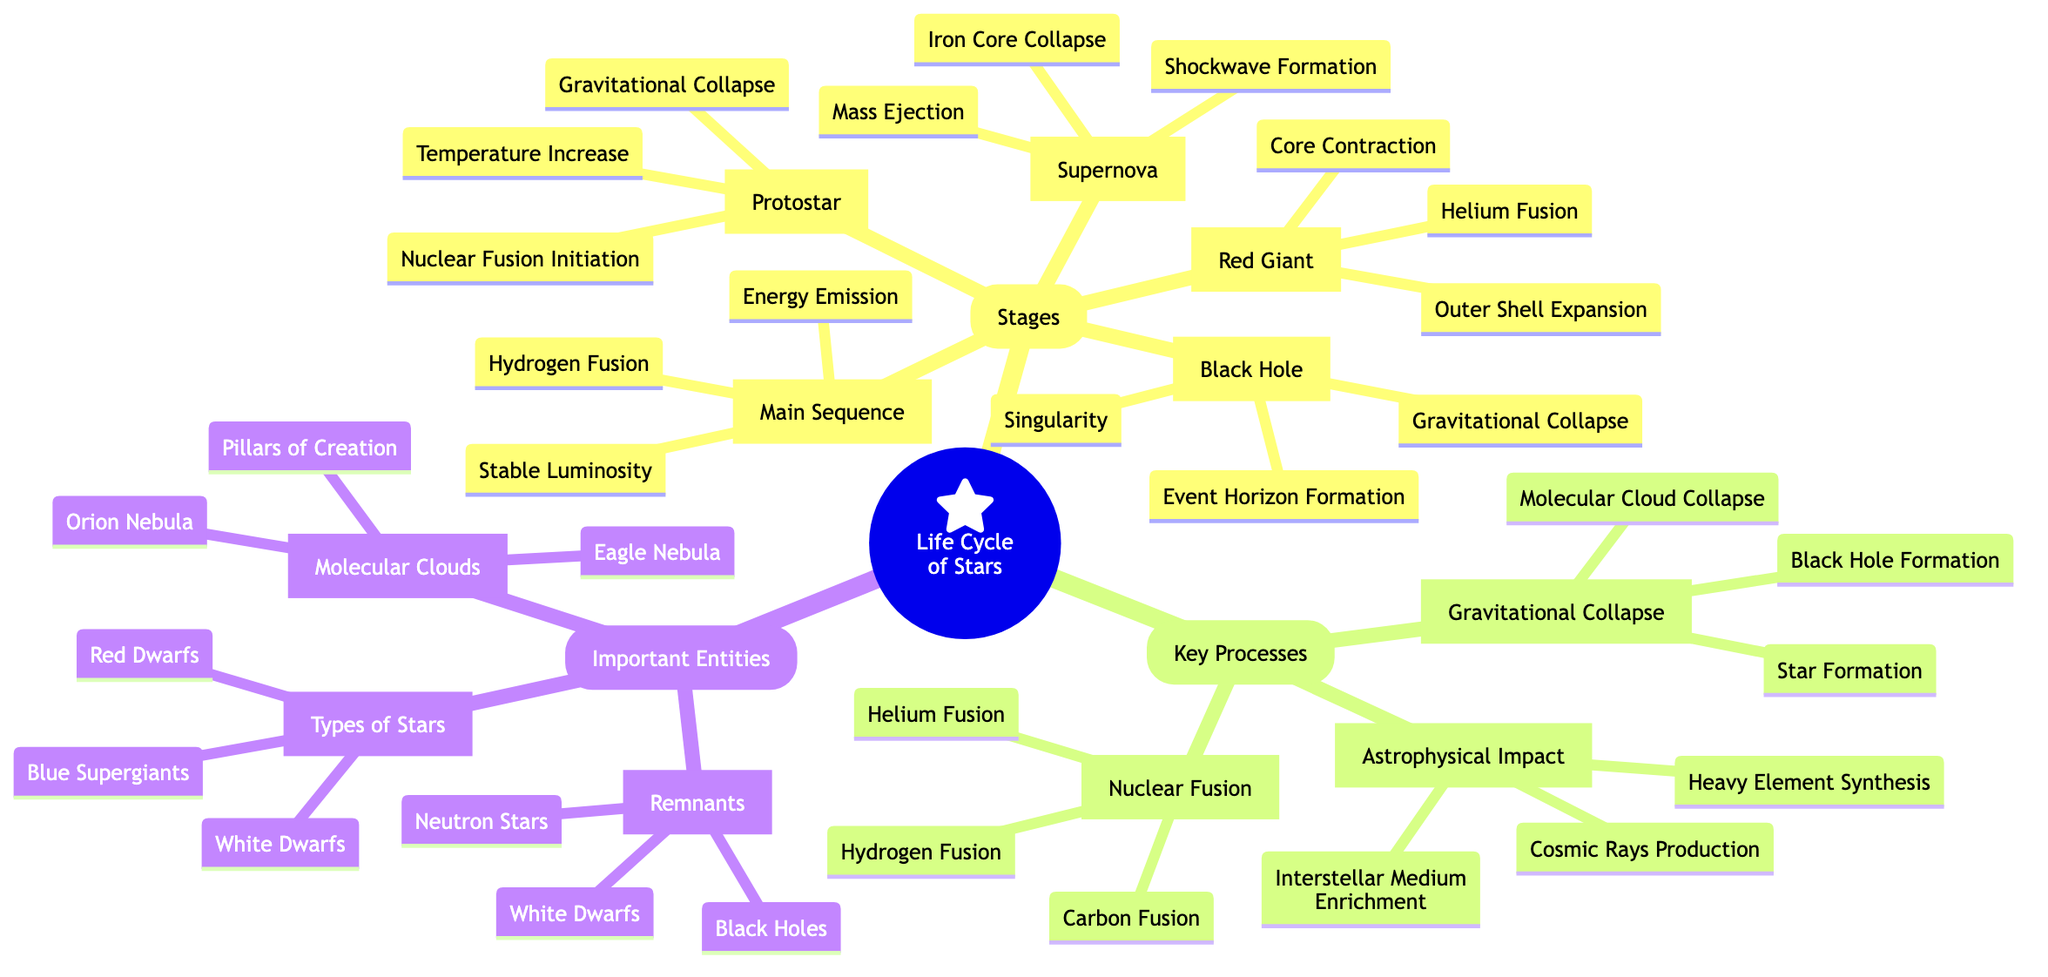What is the first stage in the life cycle of stars? According to the diagram, the first stage is explicitly labeled as "Protostar." This information can be found directly under the "Stages" section in the Mind Map.
Answer: Protostar What is a key event during the Main Sequence phase? The diagram lists several key events for the Main Sequence phase, including "Hydrogen Fusion." This is one of the prominent processes occurring during this stage.
Answer: Hydrogen Fusion How many key processes are identified in the diagram? The diagram outlines three main key processes: Nuclear Fusion, Gravitational Collapse, and Astrophysical Impact, which are clearly visible in the Key Processes section.
Answer: 3 Which type of massive stars ultimately leads to the formation of a black hole? The Supernova phase occurs in stars with masses exceeding approximately 8 solar masses, as indicated in the description for this phase, leading to black hole formation.
Answer: Massive stars What occurs during the Gravitational Collapse process? The diagram describes this process as involving "Molecular Cloud Collapse," which is a starting point for star formation, followed by star formation itself and potentially leading to black hole formation.
Answer: Molecular Cloud Collapse What is a remnant of stellar evolution? In the Important Entities section, "Black Holes" are listed as one of the remnants, along with Neutron Stars and White Dwarfs. This shows the various end states of stars after their life cycles.
Answer: Black Holes What is the relationship between a Supernova and Black Hole formation? The Supernova phase results in the "Gravitational Collapse," which is necessary for the eventual formation of a black hole. This progression indicates that supernovae lead to black holes.
Answer: Supernova leads to Black Hole How does Helium Fusion relate to the evolution of a star? As detailed in the Red Giant section, "Helium Fusion" occurs after "Core Contraction" and "Outer Shell Expansion," indicating it is a significant event in that stage of evolution.
Answer: Helium Fusion What are molecular clouds described as? In the Important Entities section, molecular clouds are characterized as "Large regions of gas and dust, the birthplace of stars," summarizing their crucial role in star formation.
Answer: Birthplace of stars 